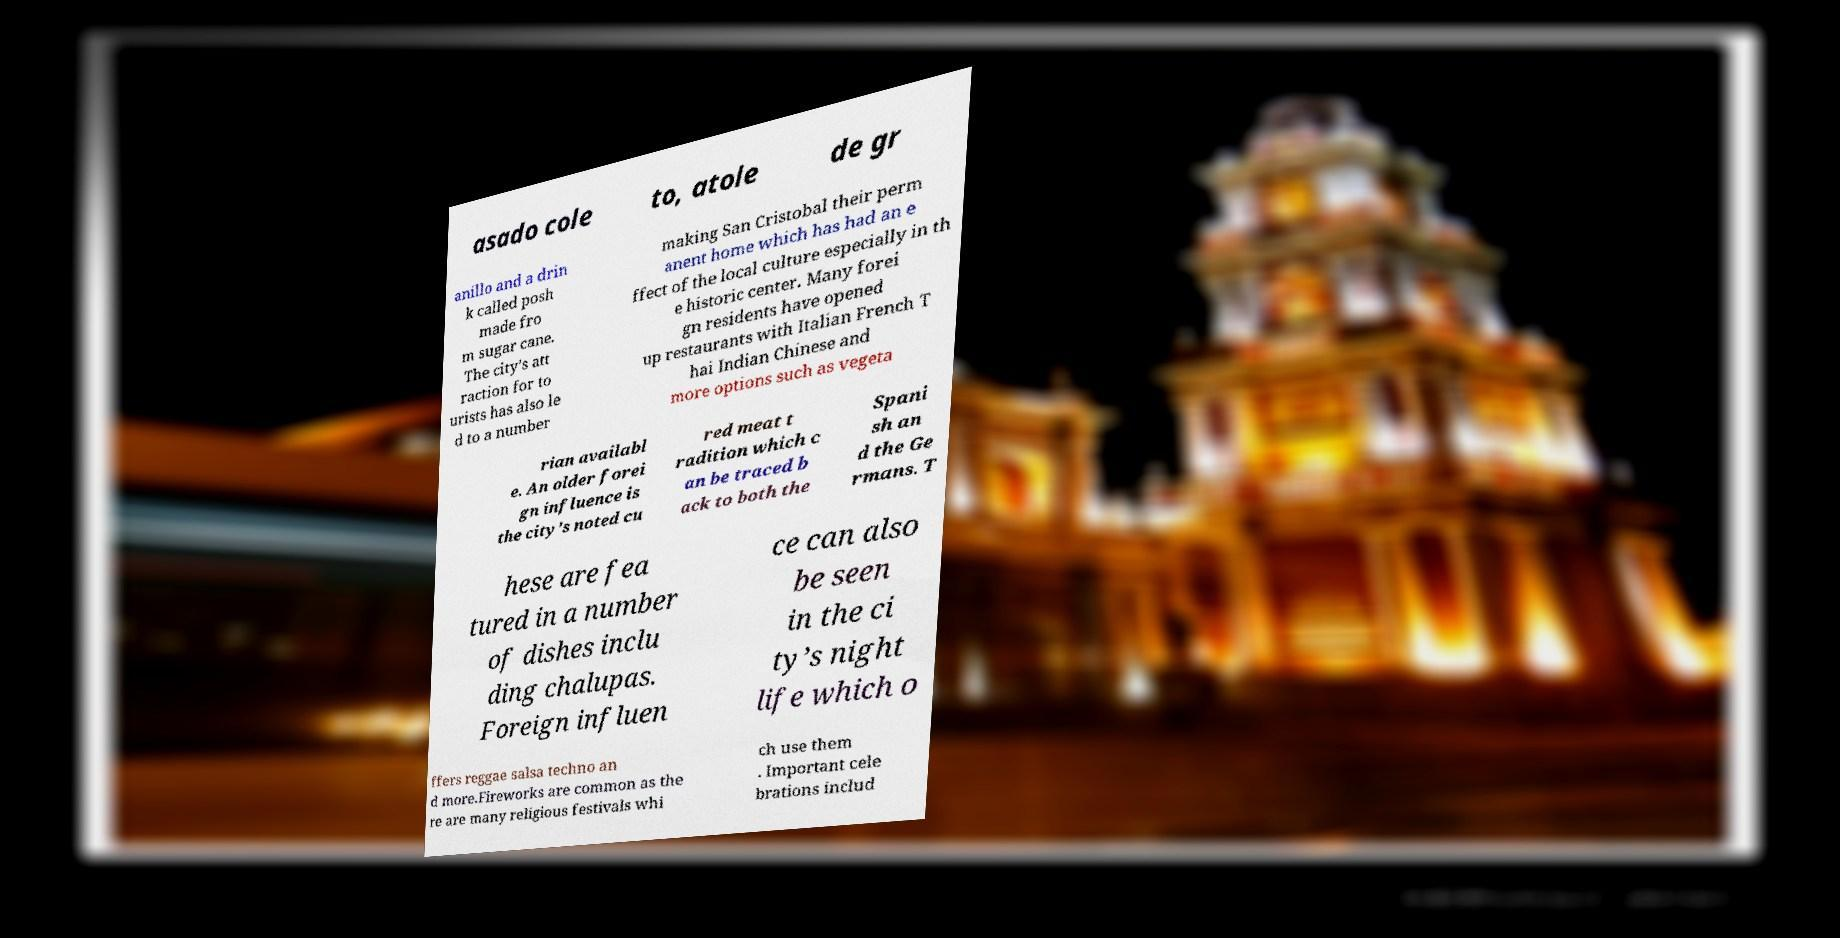Can you read and provide the text displayed in the image?This photo seems to have some interesting text. Can you extract and type it out for me? asado cole to, atole de gr anillo and a drin k called posh made fro m sugar cane. The city’s att raction for to urists has also le d to a number making San Cristobal their perm anent home which has had an e ffect of the local culture especially in th e historic center. Many forei gn residents have opened up restaurants with Italian French T hai Indian Chinese and more options such as vegeta rian availabl e. An older forei gn influence is the city’s noted cu red meat t radition which c an be traced b ack to both the Spani sh an d the Ge rmans. T hese are fea tured in a number of dishes inclu ding chalupas. Foreign influen ce can also be seen in the ci ty’s night life which o ffers reggae salsa techno an d more.Fireworks are common as the re are many religious festivals whi ch use them . Important cele brations includ 